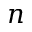<formula> <loc_0><loc_0><loc_500><loc_500>n</formula> 